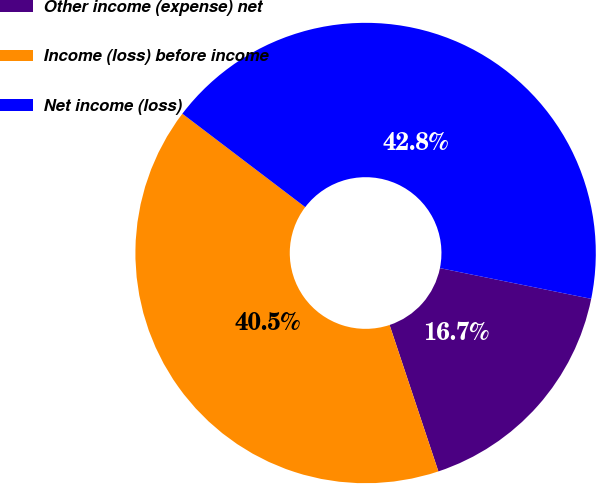Convert chart to OTSL. <chart><loc_0><loc_0><loc_500><loc_500><pie_chart><fcel>Other income (expense) net<fcel>Income (loss) before income<fcel>Net income (loss)<nl><fcel>16.69%<fcel>40.46%<fcel>42.84%<nl></chart> 